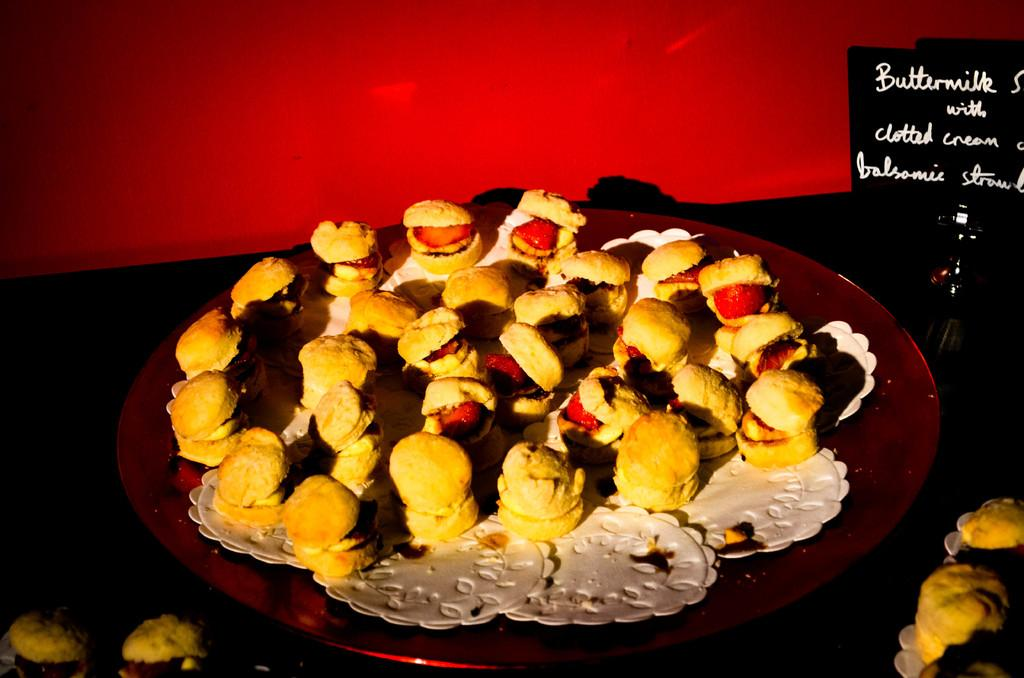What is present on the plate in the image? There is food on the plate in the image. What else can be seen beside the plate? There is a small board with text beside the plate. What is visible behind the plate? There is a wall visible behind the plate. How many kittens are lifting the plate in the image? There are no kittens present in the image, and the plate is not being lifted. 